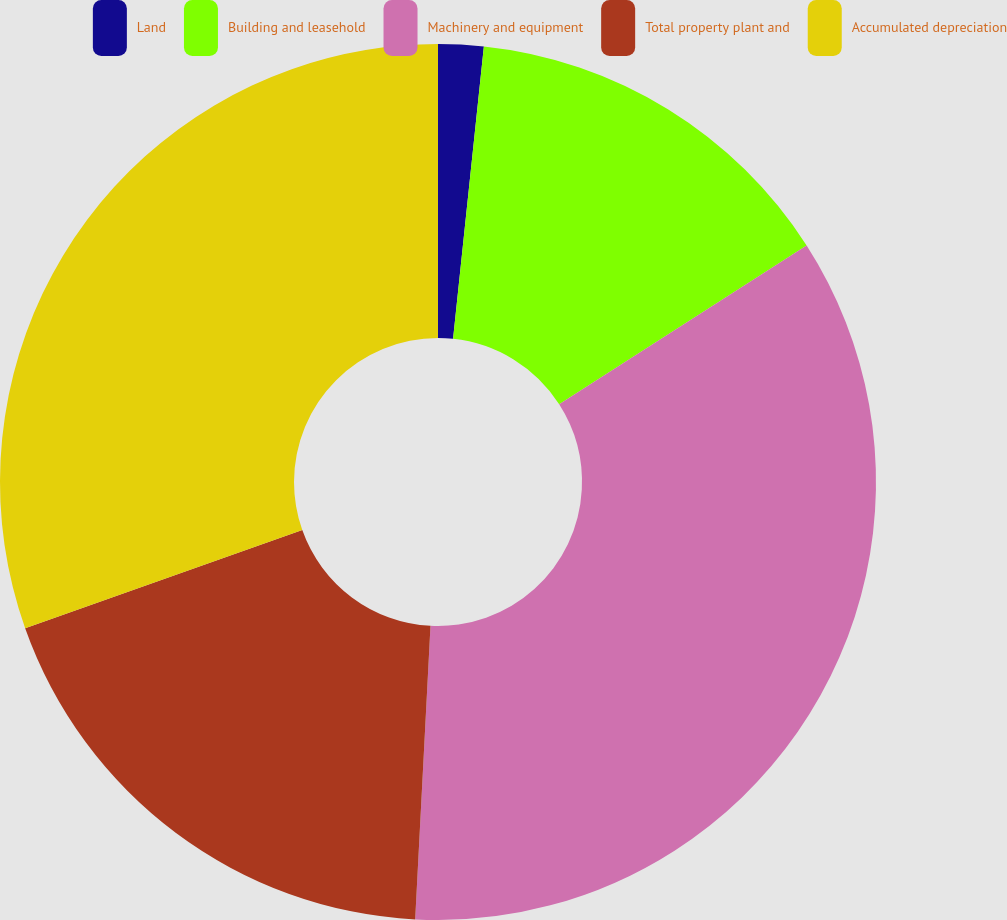Convert chart to OTSL. <chart><loc_0><loc_0><loc_500><loc_500><pie_chart><fcel>Land<fcel>Building and leasehold<fcel>Machinery and equipment<fcel>Total property plant and<fcel>Accumulated depreciation<nl><fcel>1.67%<fcel>14.25%<fcel>34.91%<fcel>18.75%<fcel>30.42%<nl></chart> 